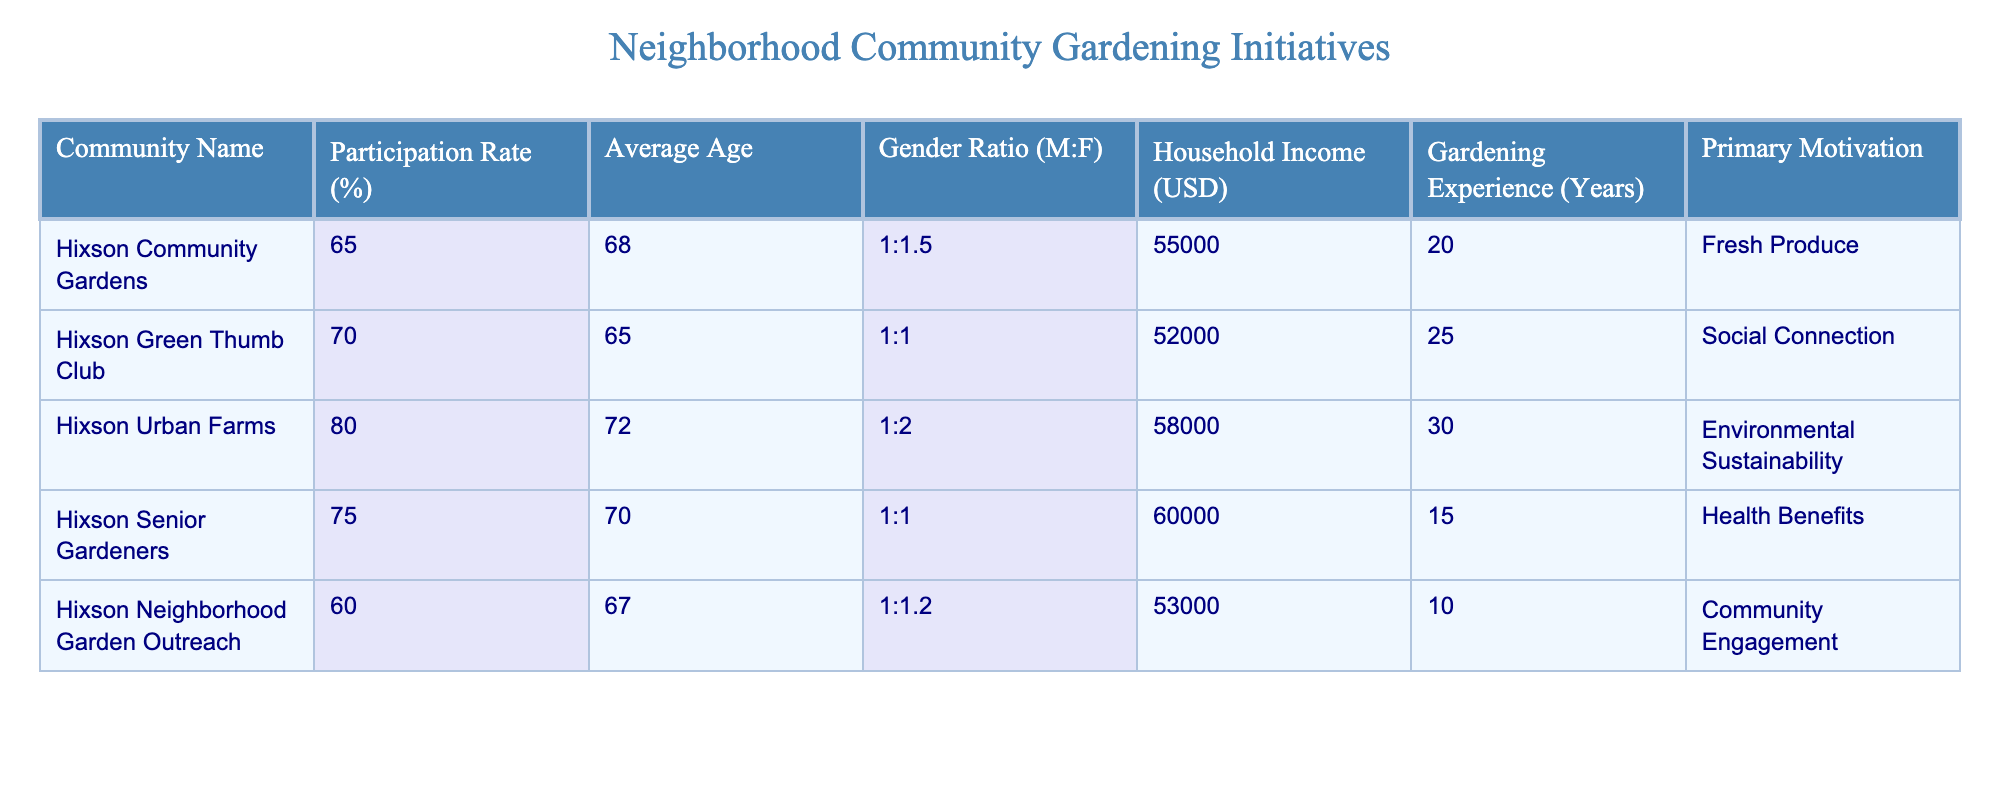What is the participation rate of the Hixson Senior Gardeners? From the table, I can locate the "Hixson Senior Gardeners" row and read the corresponding value in the "Participation Rate (%)" column, which is 75%.
Answer: 75% What is the average age of participants in the Hixson Green Thumb Club? Looking at the "Hixson Green Thumb Club" row, the "Average Age" column shows the value of 65 years.
Answer: 65 Which gardening initiative has the highest participation rate, and what is that rate? By examining the participation rates of all the initiatives listed, Hixson Urban Farms has the highest rate at 80%.
Answer: Hixson Urban Farms, 80% Is the gender ratio for Hixson Neighborhood Garden Outreach balanced? The gender ratio for Hixson Neighborhood Garden Outreach is 1:1.2, indicating there are more females than males, thus it's not perfectly balanced.
Answer: No What is the sum of household incomes for all the gardening initiatives in Hixson? To find the sum, I add the household incomes from all rows: 55000 + 52000 + 58000 + 60000 + 53000 = 280000. Therefore, the total household income is 280000 USD.
Answer: 280000 What is the average gardening experience across all initiatives? To calculate the average, I add all the gardening experience years (20 + 25 + 30 + 15 + 10 = 100) and divide by the number of initiatives (5): 100/5 = 20 years.
Answer: 20 Does the Hixson Urban Farms' primary motivation align with environmental sustainability? Yes, upon checking the "Primary Motivation" for Hixson Urban Farms, it states "Environmental Sustainability," which matches the question's criteria.
Answer: Yes Which gardening initiative has the lowest average age, and what is that age? I review the average ages in the table, finding that Hixson Green Thumb Club has the lowest average age at 65 years.
Answer: Hixson Green Thumb Club, 65 What is the difference in participation rates between Hixson Community Gardens and Hixson Urban Farms? The participation rate for Hixson Community Gardens is 65%, and for Hixson Urban Farms, it is 80%. The difference is calculated as 80 - 65 = 15%.
Answer: 15% 